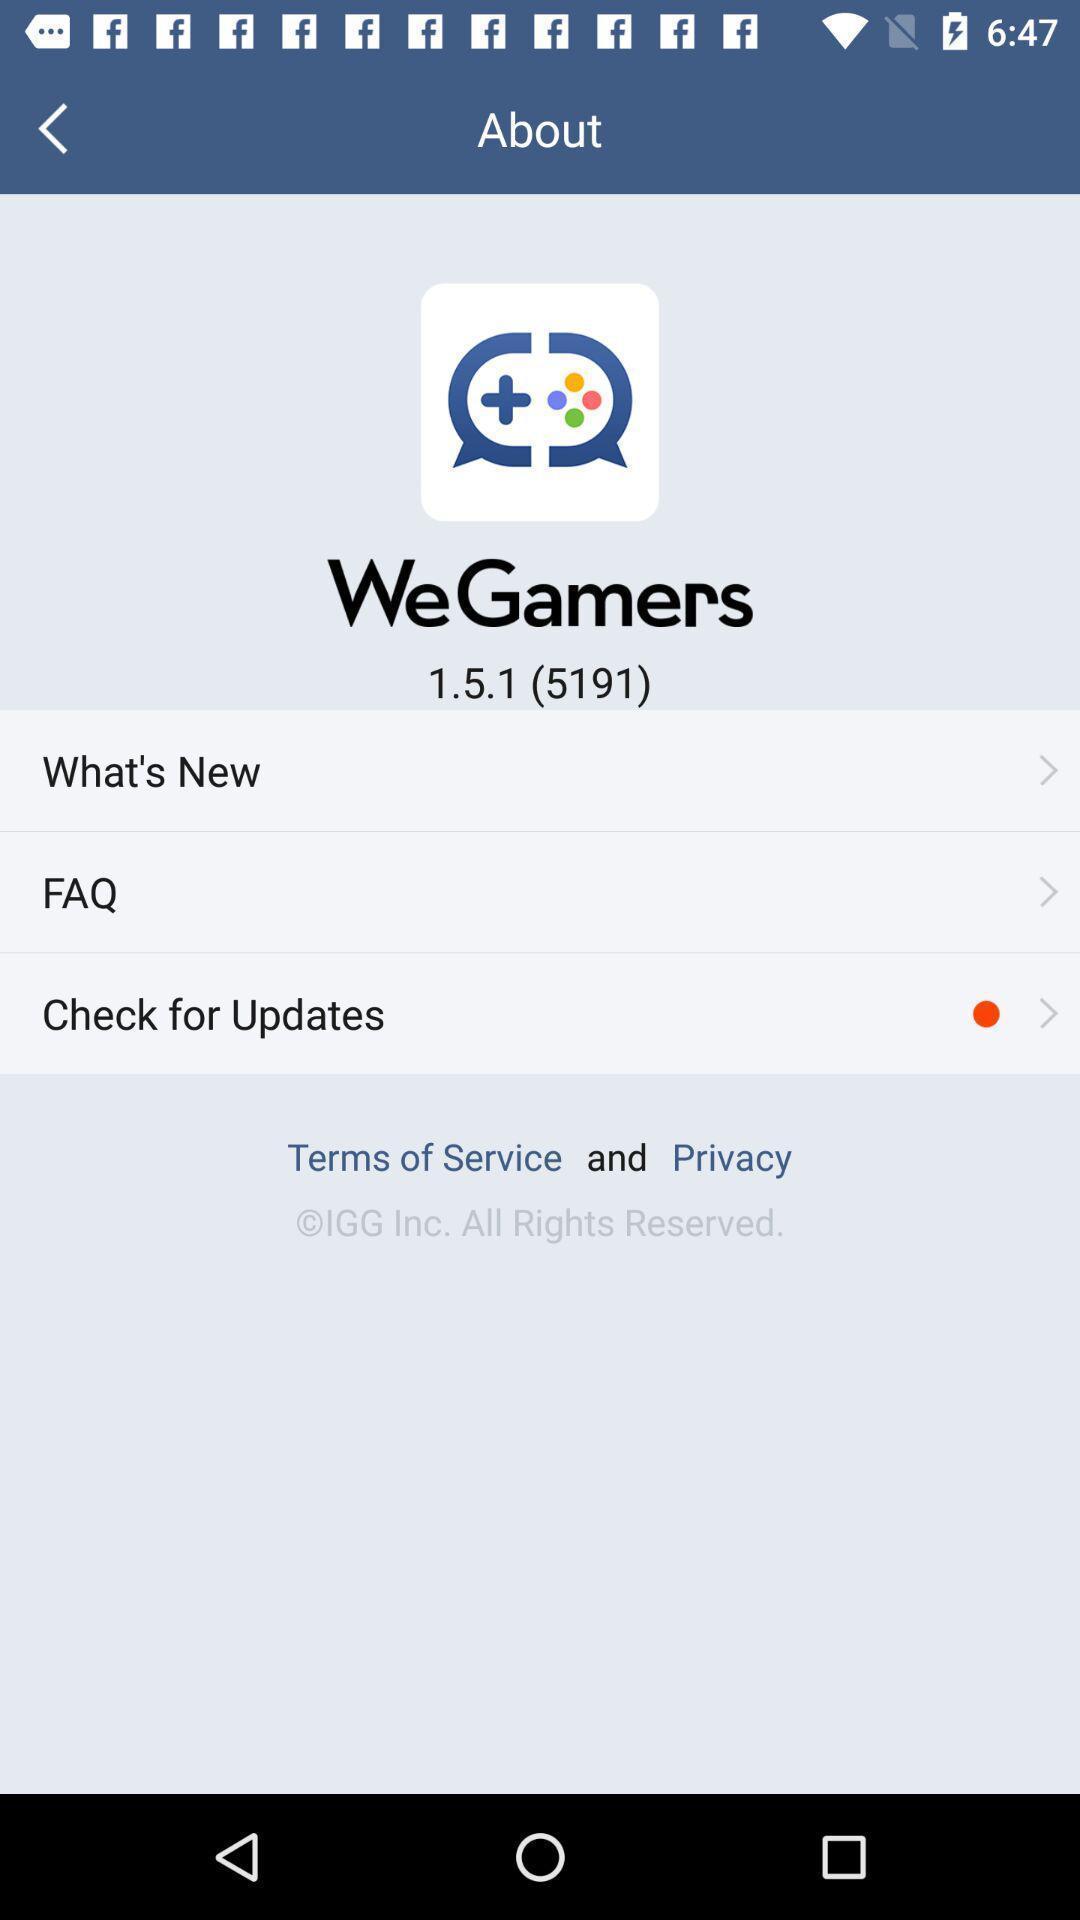Describe the content in this image. Screen shows multiple options in a gaming application. 